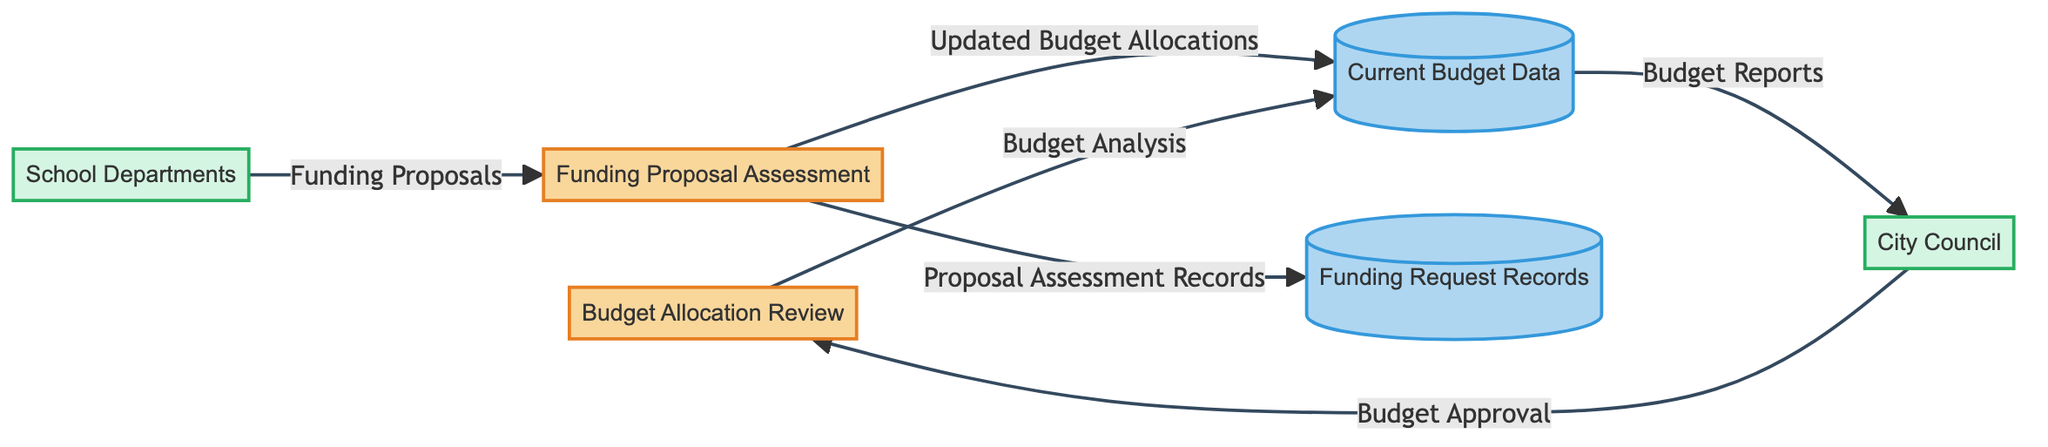What is the first process in the diagram? The first process identified in the diagram is "Budget Allocation Review," which is labeled with the ID 1.
Answer: Budget Allocation Review How many data stores are present in the diagram? The diagram lists two data stores: "Current Budget Data" and "Funding Request Records." Thus, the count is 2.
Answer: 2 Who is the external entity that requests funding proposals? The external entity that requests funding proposals is labeled as "School Departments," identified with the ID EE2.
Answer: School Departments What is the output from the "Budget Allocation Review" process? The output from the "Budget Allocation Review" process is directed to "Current Budget Data" and is labeled "Budget Analysis."
Answer: Budget Analysis Which external entity provides “Budget Approval”? The external entity that provides "Budget Approval" is the "City Council," indicated by the ID EE1.
Answer: City Council What data flow represents the records of assessed funding proposals? The data flow that represents the records of assessed funding proposals is labeled "Proposal Assessment Records" and flows from "Funding Proposal Assessment" to "Funding Request Records."
Answer: Proposal Assessment Records What is the relationship between “Funding Proposal Assessment” and “Current Budget Data”? "Funding Proposal Assessment" contributes updated information to "Current Budget Data" via the data flow named "Updated Budget Allocations." This implies that the assessment influences the current budget.
Answer: Updated Budget Allocations How many processes are involved in this diagram? The diagram identifies two processes: "Budget Allocation Review" and "Funding Proposal Assessment." Therefore, the number of processes is 2.
Answer: 2 Which process receives "Funding Proposals" from the external entity? The process that receives "Funding Proposals" from the external entity is "Funding Proposal Assessment," as indicated in the data flow.
Answer: Funding Proposal Assessment 